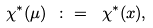Convert formula to latex. <formula><loc_0><loc_0><loc_500><loc_500>\chi ^ { * } ( \mu ) \ \colon = \ \chi ^ { * } ( x ) ,</formula> 